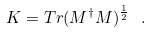Convert formula to latex. <formula><loc_0><loc_0><loc_500><loc_500>K = T r ( M ^ { \dagger } M ) ^ { \frac { 1 } { 2 } } \ .</formula> 